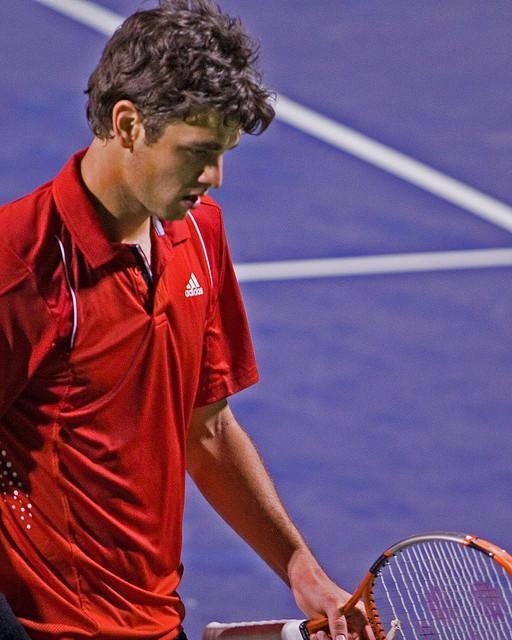How many bowls are there?
Give a very brief answer. 0. 